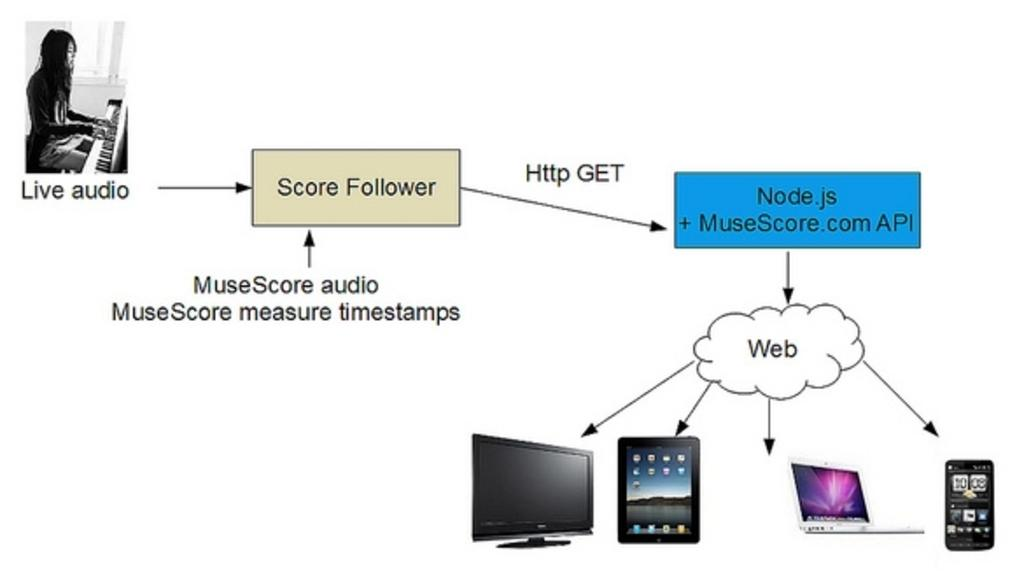<image>
Render a clear and concise summary of the photo. A screen says live audio then an arrow to score follower then another arrow to a blue box. 